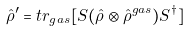Convert formula to latex. <formula><loc_0><loc_0><loc_500><loc_500>\hat { \rho } ^ { \prime } & = t r _ { g a s } [ S ( \hat { \rho } \otimes \hat { \rho } ^ { g a s } ) S ^ { \dag } ]</formula> 